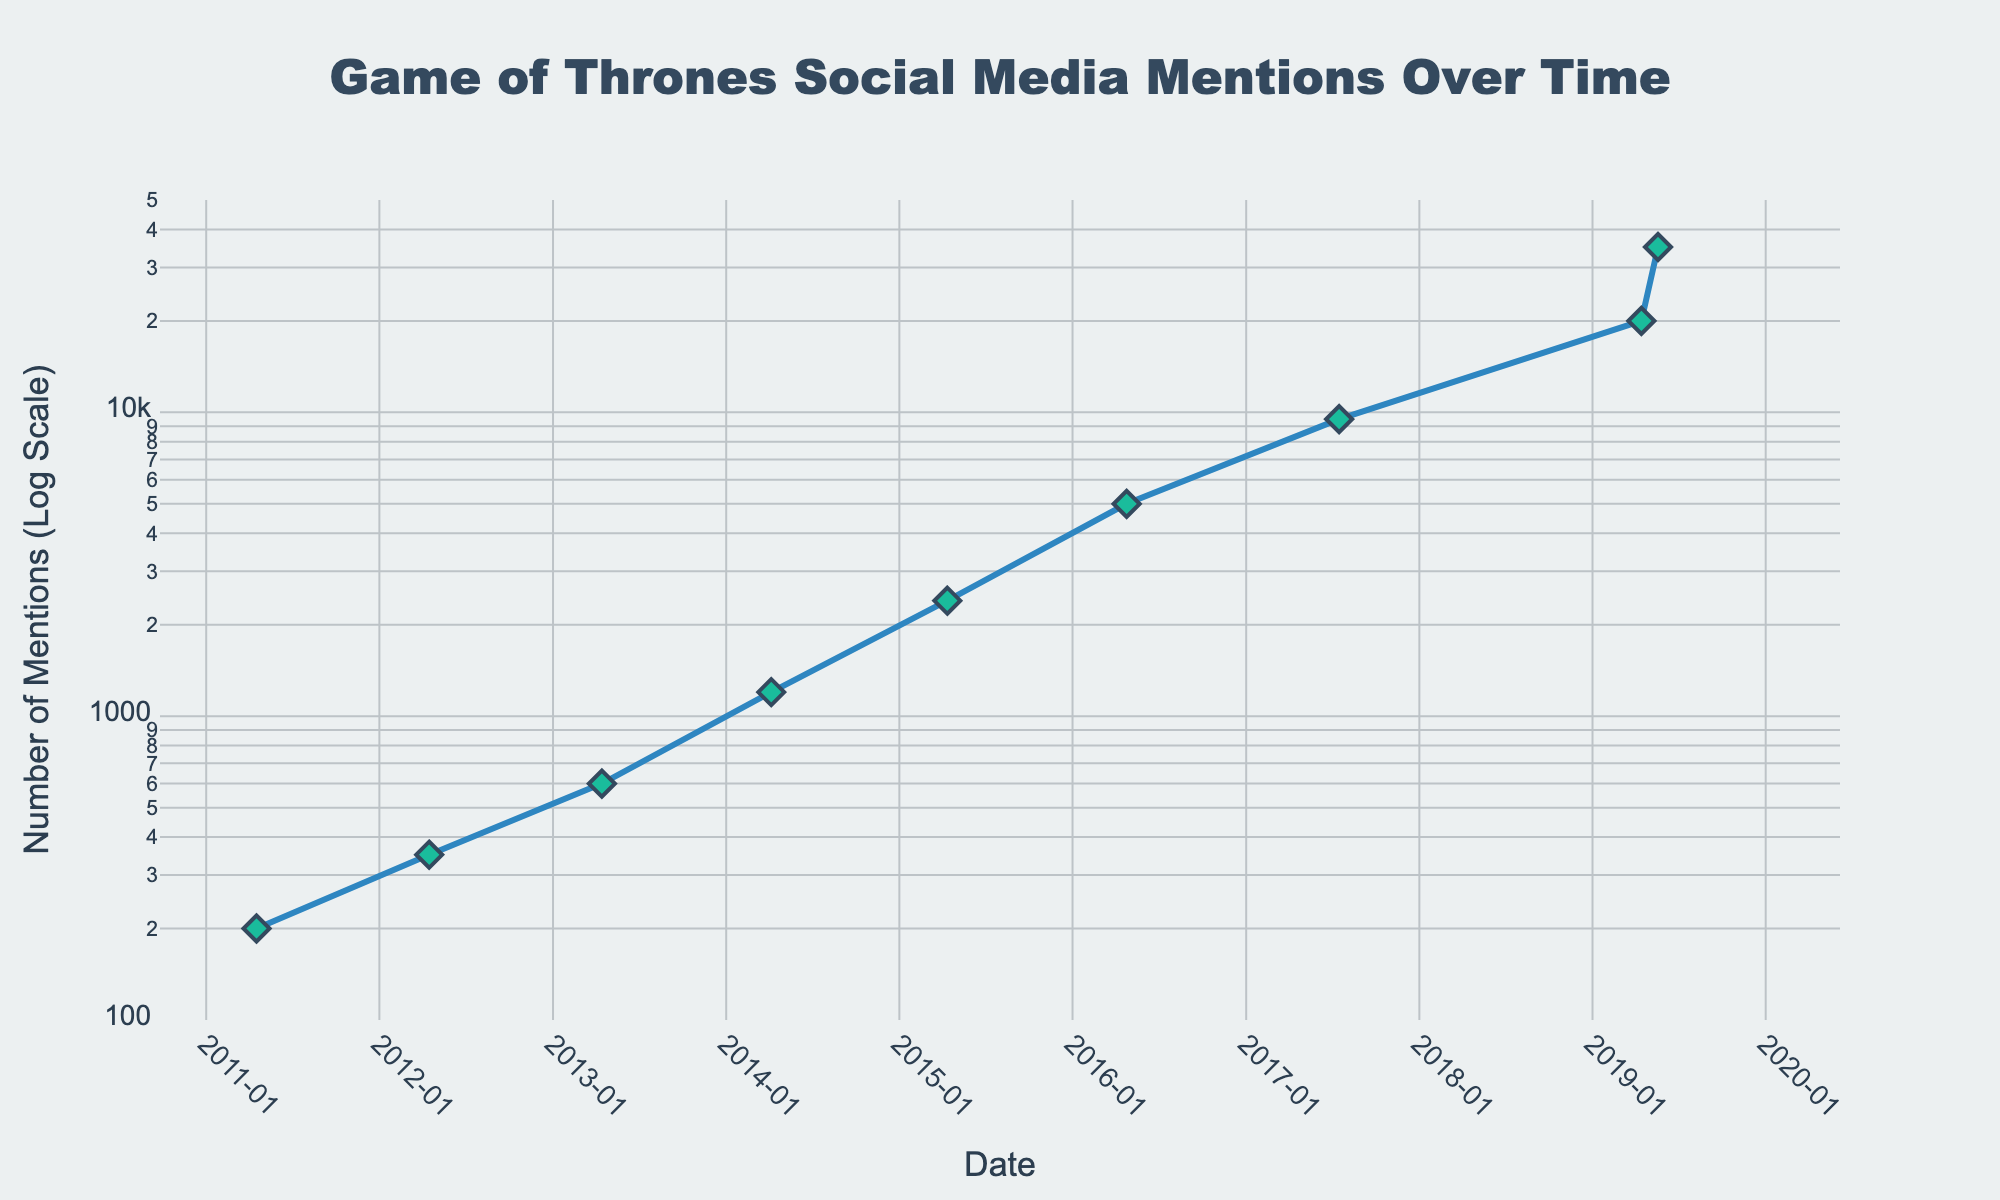When does the plot title refer to? The title of the plot is "Game of Thrones Social Media Mentions Over Time," indicating that the plot spans the timeframe from the start to the end of Game of Thrones.
Answer: The timeframe of the plot is from the start to the end of Game of Thrones How many data points are shown in the plot? The plot shows one data point for each year from 2011 to 2019, except there are two points in 2019.
Answer: 9 What is the y-axis labeled as? The y-axis is labeled "Number of Mentions (Log Scale)," indicating that the y-axis uses a logarithmic scale.
Answer: Number of Mentions (Log Scale) When do social media mentions see the first major increase? Social media mentions see the first major increase between 2013 and 2014, where the mentions rise from 600 to 1200.
Answer: Between 2013 and 2014 What is the significance of the annotation on the plot? The annotation on the plot marks the "Series Finale" and is placed at the final data point in 2019, indicating a notable moment with a sharp rise in mentions.
Answer: Series Finale What are the colors used for the line and markers? The line is colored blue with diamond-shaped markers that are green with a dark outline.
Answer: Blue line and green markers How does the number of mentions change from 2016 to 2017? From 2016 to 2017, the number of mentions increases from 5000 to 9500, nearly doubling in value.
Answer: They nearly double What is the approximate logarithmic range of the y-axis? The logarithmic range of the y-axis is from 2 (logarithm of 100) to around 4.5 (logarithm of 50000).
Answer: From 2 to 4.5 What is the series finale's number of mentions, and how does it compare to the previous data point? The series finale has 35000 mentions. The previous data point in 2019 shows 20000 mentions, so the series finale saw a rise of 15000 mentions.
Answer: 35000 mentions, increase of 15000 What trend is observed in the data points over time? The plot shows a consistent increasing trend in social media mentions from 2011 to 2019, peaking at the series finale.
Answer: Increasing trend 